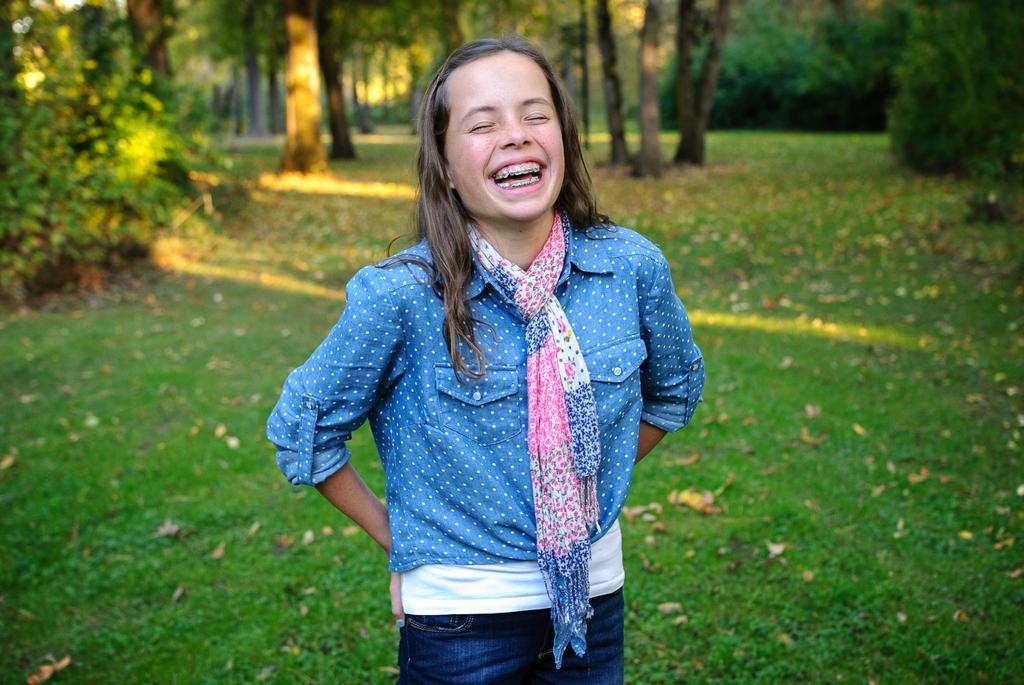In one or two sentences, can you explain what this image depicts? A girl is smiling she wore a blue color shirt, trouser. This is grass and there are trees on the back side of an image. 